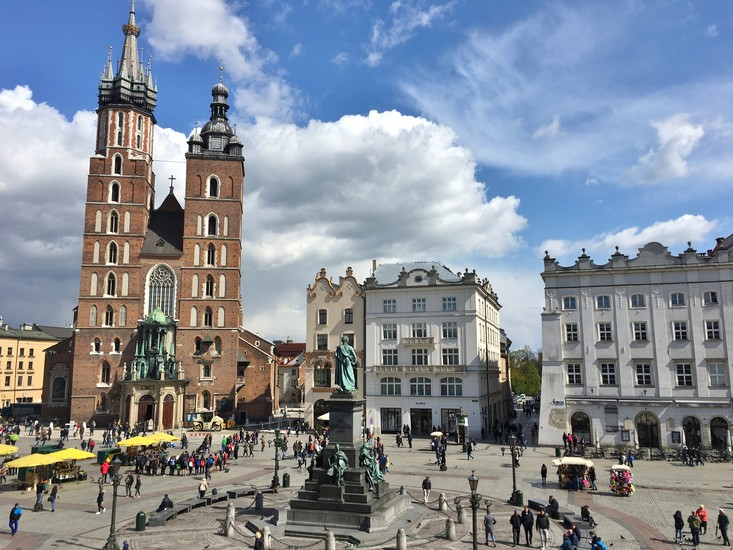What historical events took place at Krakow's Main Market Square? Krakow's Main Market Square, known as Rynek Główny, has been a central hub for many significant historical events. During the Middle Ages, it was a key trading center, hosting numerous fairs and markets. Throughout Poland's tumultuous history, it has witnessed various political and social events, including royal processions, public executions, and demonstrations. During World War II, the square was a focal point for Nazi occupation, and the buildings surrounding it were repurposed for administrative use. In contemporary times, it hosts cultural festivals, parades, and celebrations, continuing its legacy as a vibrant center of activity. 